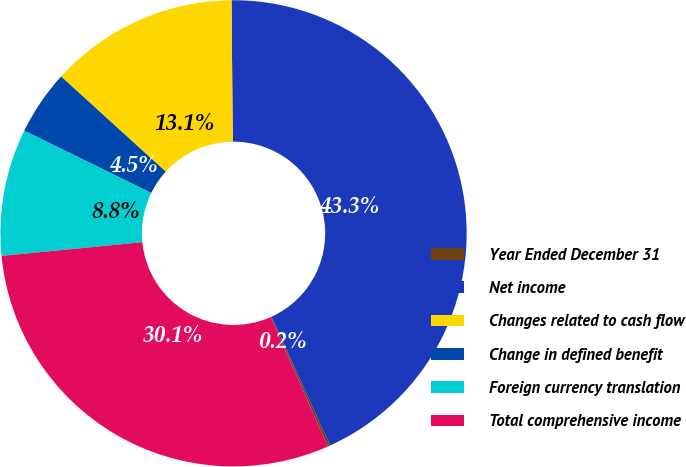<chart> <loc_0><loc_0><loc_500><loc_500><pie_chart><fcel>Year Ended December 31<fcel>Net income<fcel>Changes related to cash flow<fcel>Change in defined benefit<fcel>Foreign currency translation<fcel>Total comprehensive income<nl><fcel>0.17%<fcel>43.34%<fcel>13.12%<fcel>4.49%<fcel>8.8%<fcel>30.09%<nl></chart> 